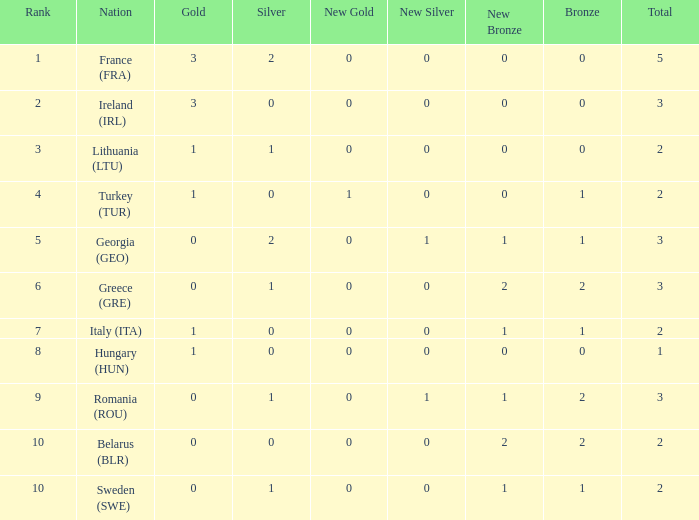What are the most bronze medals in a rank more than 1 with a total larger than 3? None. 